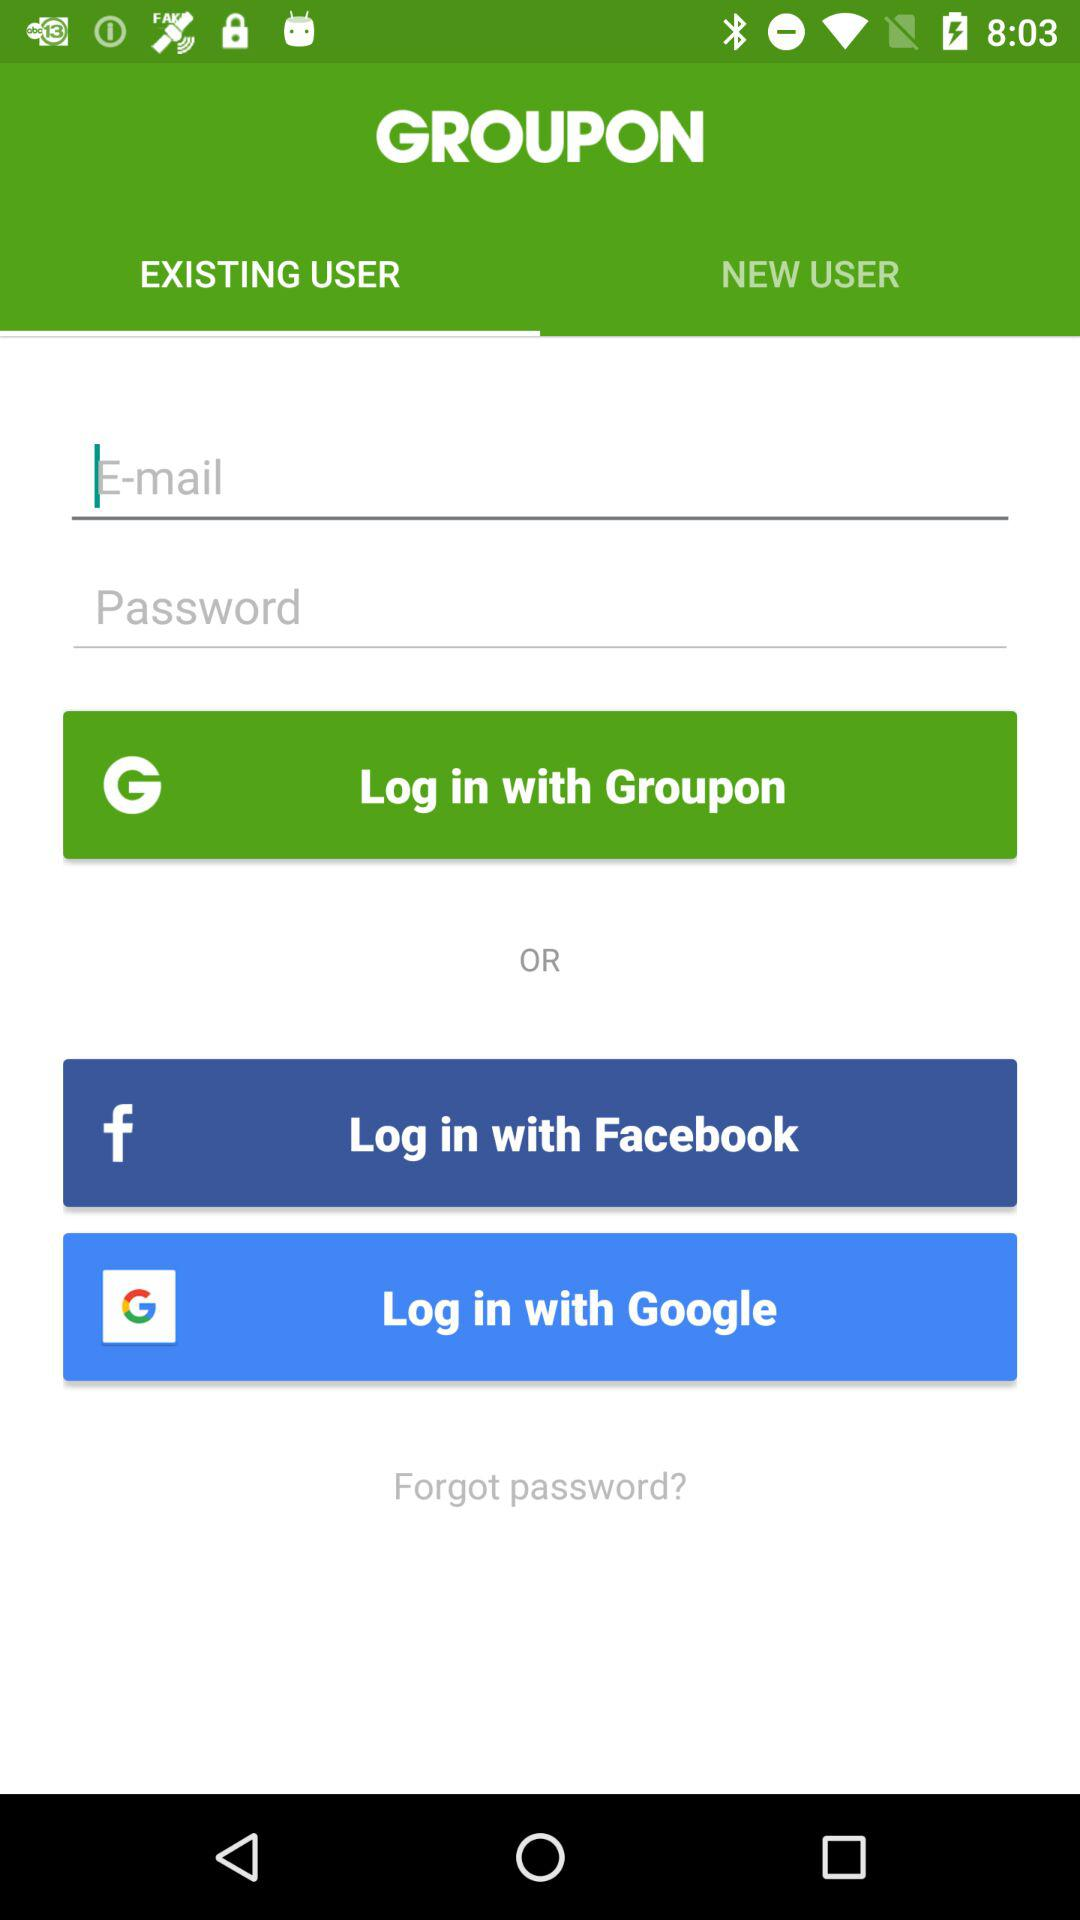How many text inputs are there for signing in?
Answer the question using a single word or phrase. 2 